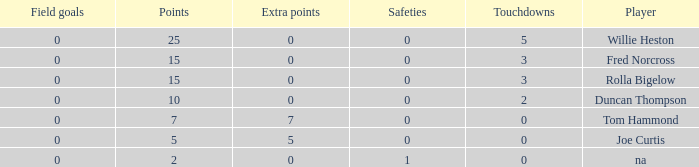Which Points is the lowest one that has Touchdowns smaller than 2, and an Extra points of 7, and a Field goals smaller than 0? None. 